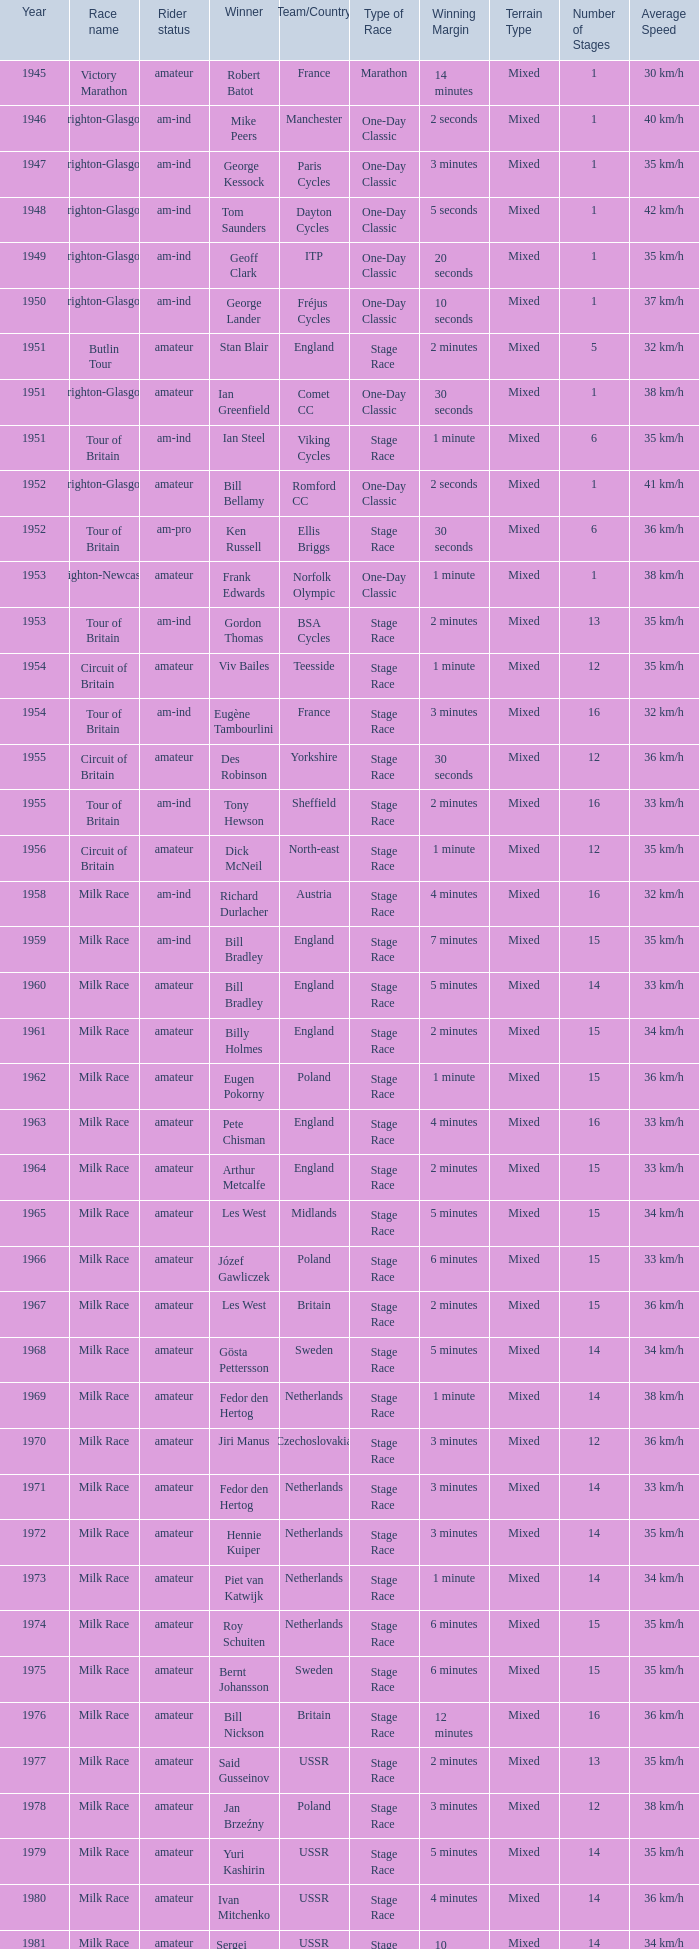What is the rider status for the 1971 netherlands team? Amateur. 